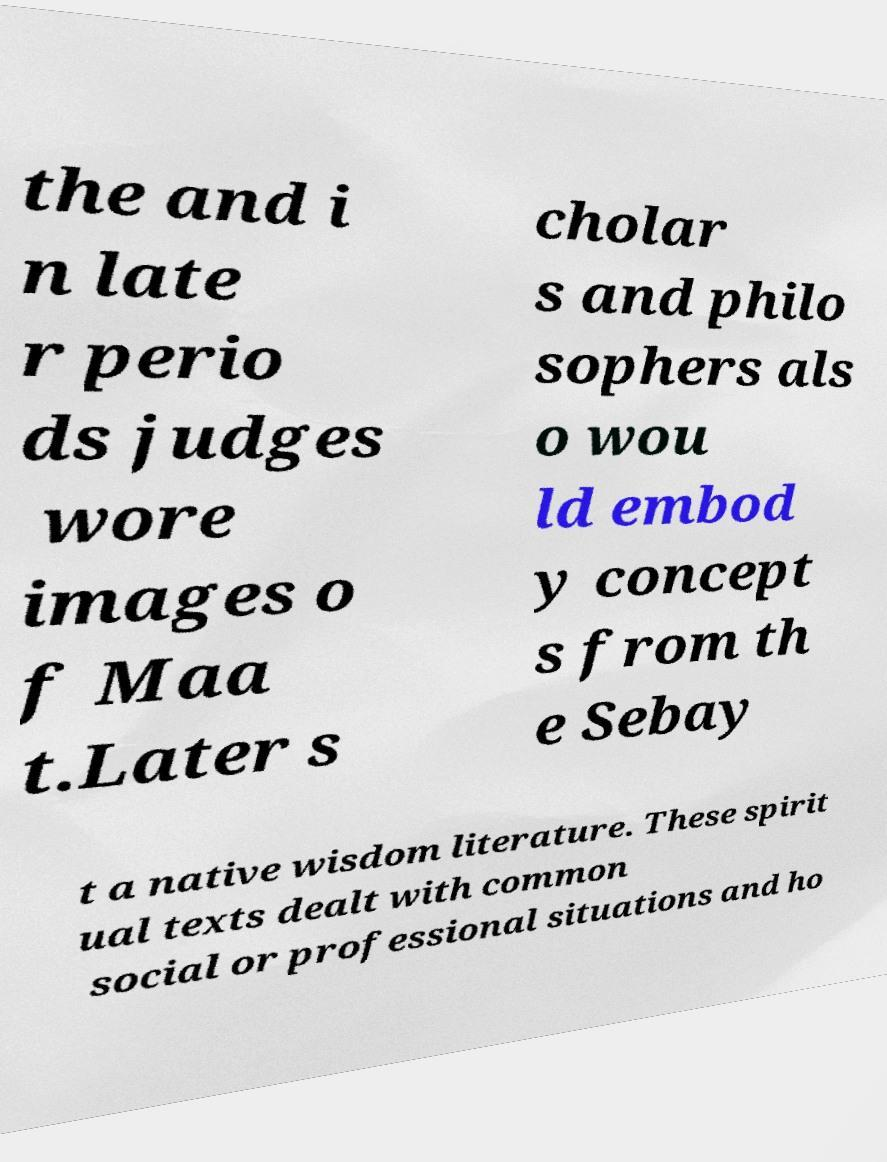Please identify and transcribe the text found in this image. the and i n late r perio ds judges wore images o f Maa t.Later s cholar s and philo sophers als o wou ld embod y concept s from th e Sebay t a native wisdom literature. These spirit ual texts dealt with common social or professional situations and ho 